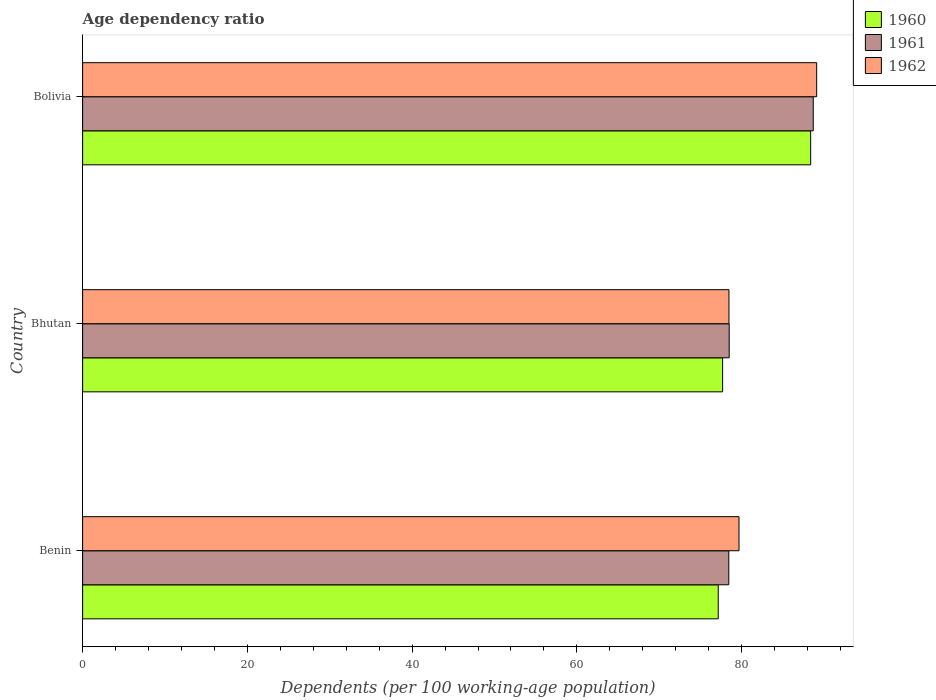How many different coloured bars are there?
Offer a terse response. 3. How many groups of bars are there?
Provide a succinct answer. 3. Are the number of bars on each tick of the Y-axis equal?
Your answer should be compact. Yes. What is the label of the 3rd group of bars from the top?
Ensure brevity in your answer.  Benin. In how many cases, is the number of bars for a given country not equal to the number of legend labels?
Provide a succinct answer. 0. What is the age dependency ratio in in 1962 in Bolivia?
Provide a short and direct response. 89.11. Across all countries, what is the maximum age dependency ratio in in 1960?
Provide a short and direct response. 88.38. Across all countries, what is the minimum age dependency ratio in in 1960?
Give a very brief answer. 77.16. In which country was the age dependency ratio in in 1961 maximum?
Provide a succinct answer. Bolivia. In which country was the age dependency ratio in in 1960 minimum?
Offer a terse response. Benin. What is the total age dependency ratio in in 1961 in the graph?
Your answer should be compact. 245.62. What is the difference between the age dependency ratio in in 1962 in Bhutan and that in Bolivia?
Your response must be concise. -10.65. What is the difference between the age dependency ratio in in 1961 in Bolivia and the age dependency ratio in in 1962 in Benin?
Keep it short and to the point. 9.01. What is the average age dependency ratio in in 1960 per country?
Offer a very short reply. 81.07. What is the difference between the age dependency ratio in in 1962 and age dependency ratio in in 1961 in Bolivia?
Offer a very short reply. 0.41. In how many countries, is the age dependency ratio in in 1961 greater than 56 %?
Give a very brief answer. 3. What is the ratio of the age dependency ratio in in 1961 in Benin to that in Bolivia?
Your answer should be very brief. 0.88. Is the age dependency ratio in in 1962 in Benin less than that in Bolivia?
Keep it short and to the point. Yes. Is the difference between the age dependency ratio in in 1962 in Benin and Bolivia greater than the difference between the age dependency ratio in in 1961 in Benin and Bolivia?
Give a very brief answer. Yes. What is the difference between the highest and the second highest age dependency ratio in in 1962?
Provide a short and direct response. 9.43. What is the difference between the highest and the lowest age dependency ratio in in 1960?
Your response must be concise. 11.22. In how many countries, is the age dependency ratio in in 1960 greater than the average age dependency ratio in in 1960 taken over all countries?
Your response must be concise. 1. Is the sum of the age dependency ratio in in 1961 in Benin and Bhutan greater than the maximum age dependency ratio in in 1960 across all countries?
Provide a short and direct response. Yes. What does the 2nd bar from the top in Benin represents?
Keep it short and to the point. 1961. What does the 1st bar from the bottom in Bhutan represents?
Your answer should be very brief. 1960. Is it the case that in every country, the sum of the age dependency ratio in in 1962 and age dependency ratio in in 1960 is greater than the age dependency ratio in in 1961?
Offer a terse response. Yes. How many bars are there?
Your response must be concise. 9. Are the values on the major ticks of X-axis written in scientific E-notation?
Provide a succinct answer. No. How many legend labels are there?
Offer a terse response. 3. What is the title of the graph?
Your response must be concise. Age dependency ratio. Does "1977" appear as one of the legend labels in the graph?
Provide a succinct answer. No. What is the label or title of the X-axis?
Your answer should be compact. Dependents (per 100 working-age population). What is the label or title of the Y-axis?
Give a very brief answer. Country. What is the Dependents (per 100 working-age population) of 1960 in Benin?
Offer a terse response. 77.16. What is the Dependents (per 100 working-age population) of 1961 in Benin?
Your response must be concise. 78.44. What is the Dependents (per 100 working-age population) of 1962 in Benin?
Offer a terse response. 79.68. What is the Dependents (per 100 working-age population) of 1960 in Bhutan?
Ensure brevity in your answer.  77.69. What is the Dependents (per 100 working-age population) of 1961 in Bhutan?
Your response must be concise. 78.49. What is the Dependents (per 100 working-age population) in 1962 in Bhutan?
Your answer should be very brief. 78.46. What is the Dependents (per 100 working-age population) in 1960 in Bolivia?
Give a very brief answer. 88.38. What is the Dependents (per 100 working-age population) of 1961 in Bolivia?
Your answer should be compact. 88.69. What is the Dependents (per 100 working-age population) in 1962 in Bolivia?
Keep it short and to the point. 89.11. Across all countries, what is the maximum Dependents (per 100 working-age population) of 1960?
Ensure brevity in your answer.  88.38. Across all countries, what is the maximum Dependents (per 100 working-age population) in 1961?
Your answer should be very brief. 88.69. Across all countries, what is the maximum Dependents (per 100 working-age population) in 1962?
Provide a short and direct response. 89.11. Across all countries, what is the minimum Dependents (per 100 working-age population) of 1960?
Your response must be concise. 77.16. Across all countries, what is the minimum Dependents (per 100 working-age population) in 1961?
Offer a very short reply. 78.44. Across all countries, what is the minimum Dependents (per 100 working-age population) in 1962?
Offer a very short reply. 78.46. What is the total Dependents (per 100 working-age population) in 1960 in the graph?
Ensure brevity in your answer.  243.22. What is the total Dependents (per 100 working-age population) in 1961 in the graph?
Ensure brevity in your answer.  245.62. What is the total Dependents (per 100 working-age population) in 1962 in the graph?
Keep it short and to the point. 247.25. What is the difference between the Dependents (per 100 working-age population) of 1960 in Benin and that in Bhutan?
Keep it short and to the point. -0.53. What is the difference between the Dependents (per 100 working-age population) in 1961 in Benin and that in Bhutan?
Ensure brevity in your answer.  -0.05. What is the difference between the Dependents (per 100 working-age population) of 1962 in Benin and that in Bhutan?
Give a very brief answer. 1.22. What is the difference between the Dependents (per 100 working-age population) of 1960 in Benin and that in Bolivia?
Your answer should be very brief. -11.22. What is the difference between the Dependents (per 100 working-age population) of 1961 in Benin and that in Bolivia?
Offer a terse response. -10.25. What is the difference between the Dependents (per 100 working-age population) in 1962 in Benin and that in Bolivia?
Provide a short and direct response. -9.43. What is the difference between the Dependents (per 100 working-age population) of 1960 in Bhutan and that in Bolivia?
Provide a short and direct response. -10.69. What is the difference between the Dependents (per 100 working-age population) of 1961 in Bhutan and that in Bolivia?
Your answer should be very brief. -10.2. What is the difference between the Dependents (per 100 working-age population) of 1962 in Bhutan and that in Bolivia?
Your answer should be compact. -10.65. What is the difference between the Dependents (per 100 working-age population) of 1960 in Benin and the Dependents (per 100 working-age population) of 1961 in Bhutan?
Provide a short and direct response. -1.33. What is the difference between the Dependents (per 100 working-age population) of 1960 in Benin and the Dependents (per 100 working-age population) of 1962 in Bhutan?
Offer a terse response. -1.3. What is the difference between the Dependents (per 100 working-age population) of 1961 in Benin and the Dependents (per 100 working-age population) of 1962 in Bhutan?
Your response must be concise. -0.02. What is the difference between the Dependents (per 100 working-age population) in 1960 in Benin and the Dependents (per 100 working-age population) in 1961 in Bolivia?
Ensure brevity in your answer.  -11.53. What is the difference between the Dependents (per 100 working-age population) in 1960 in Benin and the Dependents (per 100 working-age population) in 1962 in Bolivia?
Your response must be concise. -11.95. What is the difference between the Dependents (per 100 working-age population) in 1961 in Benin and the Dependents (per 100 working-age population) in 1962 in Bolivia?
Keep it short and to the point. -10.67. What is the difference between the Dependents (per 100 working-age population) in 1960 in Bhutan and the Dependents (per 100 working-age population) in 1961 in Bolivia?
Offer a terse response. -11. What is the difference between the Dependents (per 100 working-age population) in 1960 in Bhutan and the Dependents (per 100 working-age population) in 1962 in Bolivia?
Give a very brief answer. -11.42. What is the difference between the Dependents (per 100 working-age population) of 1961 in Bhutan and the Dependents (per 100 working-age population) of 1962 in Bolivia?
Your response must be concise. -10.62. What is the average Dependents (per 100 working-age population) of 1960 per country?
Your answer should be compact. 81.08. What is the average Dependents (per 100 working-age population) of 1961 per country?
Give a very brief answer. 81.87. What is the average Dependents (per 100 working-age population) of 1962 per country?
Give a very brief answer. 82.42. What is the difference between the Dependents (per 100 working-age population) in 1960 and Dependents (per 100 working-age population) in 1961 in Benin?
Provide a short and direct response. -1.28. What is the difference between the Dependents (per 100 working-age population) of 1960 and Dependents (per 100 working-age population) of 1962 in Benin?
Offer a terse response. -2.52. What is the difference between the Dependents (per 100 working-age population) of 1961 and Dependents (per 100 working-age population) of 1962 in Benin?
Provide a succinct answer. -1.24. What is the difference between the Dependents (per 100 working-age population) of 1960 and Dependents (per 100 working-age population) of 1961 in Bhutan?
Your response must be concise. -0.8. What is the difference between the Dependents (per 100 working-age population) of 1960 and Dependents (per 100 working-age population) of 1962 in Bhutan?
Make the answer very short. -0.77. What is the difference between the Dependents (per 100 working-age population) in 1961 and Dependents (per 100 working-age population) in 1962 in Bhutan?
Give a very brief answer. 0.03. What is the difference between the Dependents (per 100 working-age population) of 1960 and Dependents (per 100 working-age population) of 1961 in Bolivia?
Provide a succinct answer. -0.31. What is the difference between the Dependents (per 100 working-age population) of 1960 and Dependents (per 100 working-age population) of 1962 in Bolivia?
Ensure brevity in your answer.  -0.73. What is the difference between the Dependents (per 100 working-age population) of 1961 and Dependents (per 100 working-age population) of 1962 in Bolivia?
Give a very brief answer. -0.41. What is the ratio of the Dependents (per 100 working-age population) in 1960 in Benin to that in Bhutan?
Your response must be concise. 0.99. What is the ratio of the Dependents (per 100 working-age population) in 1961 in Benin to that in Bhutan?
Keep it short and to the point. 1. What is the ratio of the Dependents (per 100 working-age population) of 1962 in Benin to that in Bhutan?
Offer a very short reply. 1.02. What is the ratio of the Dependents (per 100 working-age population) of 1960 in Benin to that in Bolivia?
Provide a succinct answer. 0.87. What is the ratio of the Dependents (per 100 working-age population) of 1961 in Benin to that in Bolivia?
Offer a terse response. 0.88. What is the ratio of the Dependents (per 100 working-age population) in 1962 in Benin to that in Bolivia?
Keep it short and to the point. 0.89. What is the ratio of the Dependents (per 100 working-age population) of 1960 in Bhutan to that in Bolivia?
Your response must be concise. 0.88. What is the ratio of the Dependents (per 100 working-age population) in 1961 in Bhutan to that in Bolivia?
Provide a succinct answer. 0.88. What is the ratio of the Dependents (per 100 working-age population) in 1962 in Bhutan to that in Bolivia?
Offer a very short reply. 0.88. What is the difference between the highest and the second highest Dependents (per 100 working-age population) in 1960?
Offer a very short reply. 10.69. What is the difference between the highest and the second highest Dependents (per 100 working-age population) of 1961?
Your answer should be very brief. 10.2. What is the difference between the highest and the second highest Dependents (per 100 working-age population) of 1962?
Provide a short and direct response. 9.43. What is the difference between the highest and the lowest Dependents (per 100 working-age population) of 1960?
Give a very brief answer. 11.22. What is the difference between the highest and the lowest Dependents (per 100 working-age population) of 1961?
Give a very brief answer. 10.25. What is the difference between the highest and the lowest Dependents (per 100 working-age population) of 1962?
Ensure brevity in your answer.  10.65. 